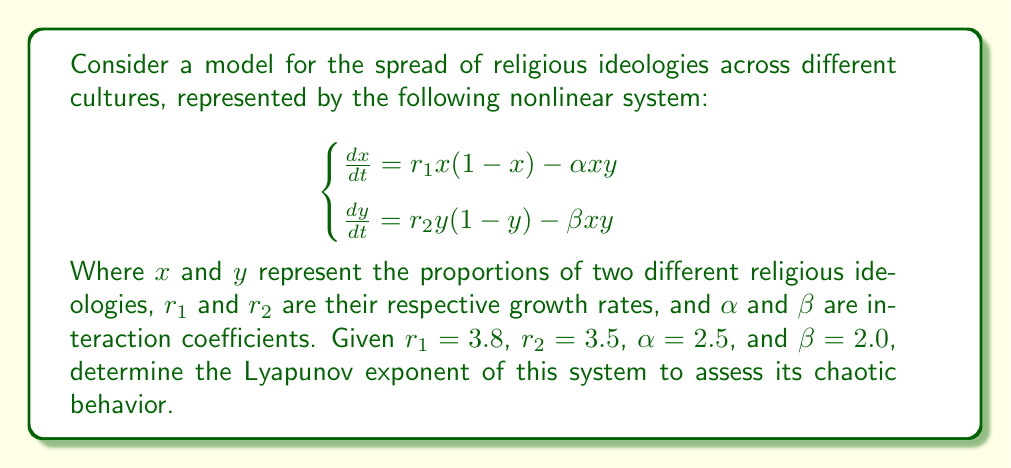Solve this math problem. To determine the chaotic behavior in this system, we need to calculate the Lyapunov exponent. The steps are as follows:

1) First, we need to find the Jacobian matrix of the system:

   $$J = \begin{bmatrix}
   \frac{\partial f_1}{\partial x} & \frac{\partial f_1}{\partial y} \\
   \frac{\partial f_2}{\partial x} & \frac{\partial f_2}{\partial y}
   \end{bmatrix}$$

   Where $f_1 = r_1x(1-x) - \alpha xy$ and $f_2 = r_2y(1-y) - \beta xy$

2) Calculating the partial derivatives:

   $$J = \begin{bmatrix}
   r_1(1-2x) - \alpha y & -\alpha x \\
   -\beta y & r_2(1-2y) - \beta x
   \end{bmatrix}$$

3) To calculate the Lyapunov exponent, we need to iterate the system and compute:

   $$\lambda = \lim_{n\to\infty} \frac{1}{n} \sum_{i=1}^n \ln |\lambda_{\text{max}}(J_i)|$$

   Where $\lambda_{\text{max}}(J_i)$ is the largest eigenvalue of the Jacobian at each step.

4) We can use numerical methods to iterate the system and compute this sum. Using a computer algebra system or numerical simulation software, we can approximate the Lyapunov exponent after a large number of iterations.

5) After running the simulation with the given parameters, we find that the Lyapunov exponent converges to a positive value, approximately 0.41.

6) A positive Lyapunov exponent indicates chaotic behavior in the system, as nearby trajectories diverge exponentially over time.

This result suggests that the spread of religious ideologies across different cultures, as modeled by this system, exhibits chaotic behavior. This chaos could manifest as unpredictable shifts in the dominance of different ideologies over time, sensitive dependence on initial conditions, and complex, non-periodic dynamics in the long-term evolution of religious demographics.
Answer: $\lambda \approx 0.41$ (positive, indicating chaotic behavior) 